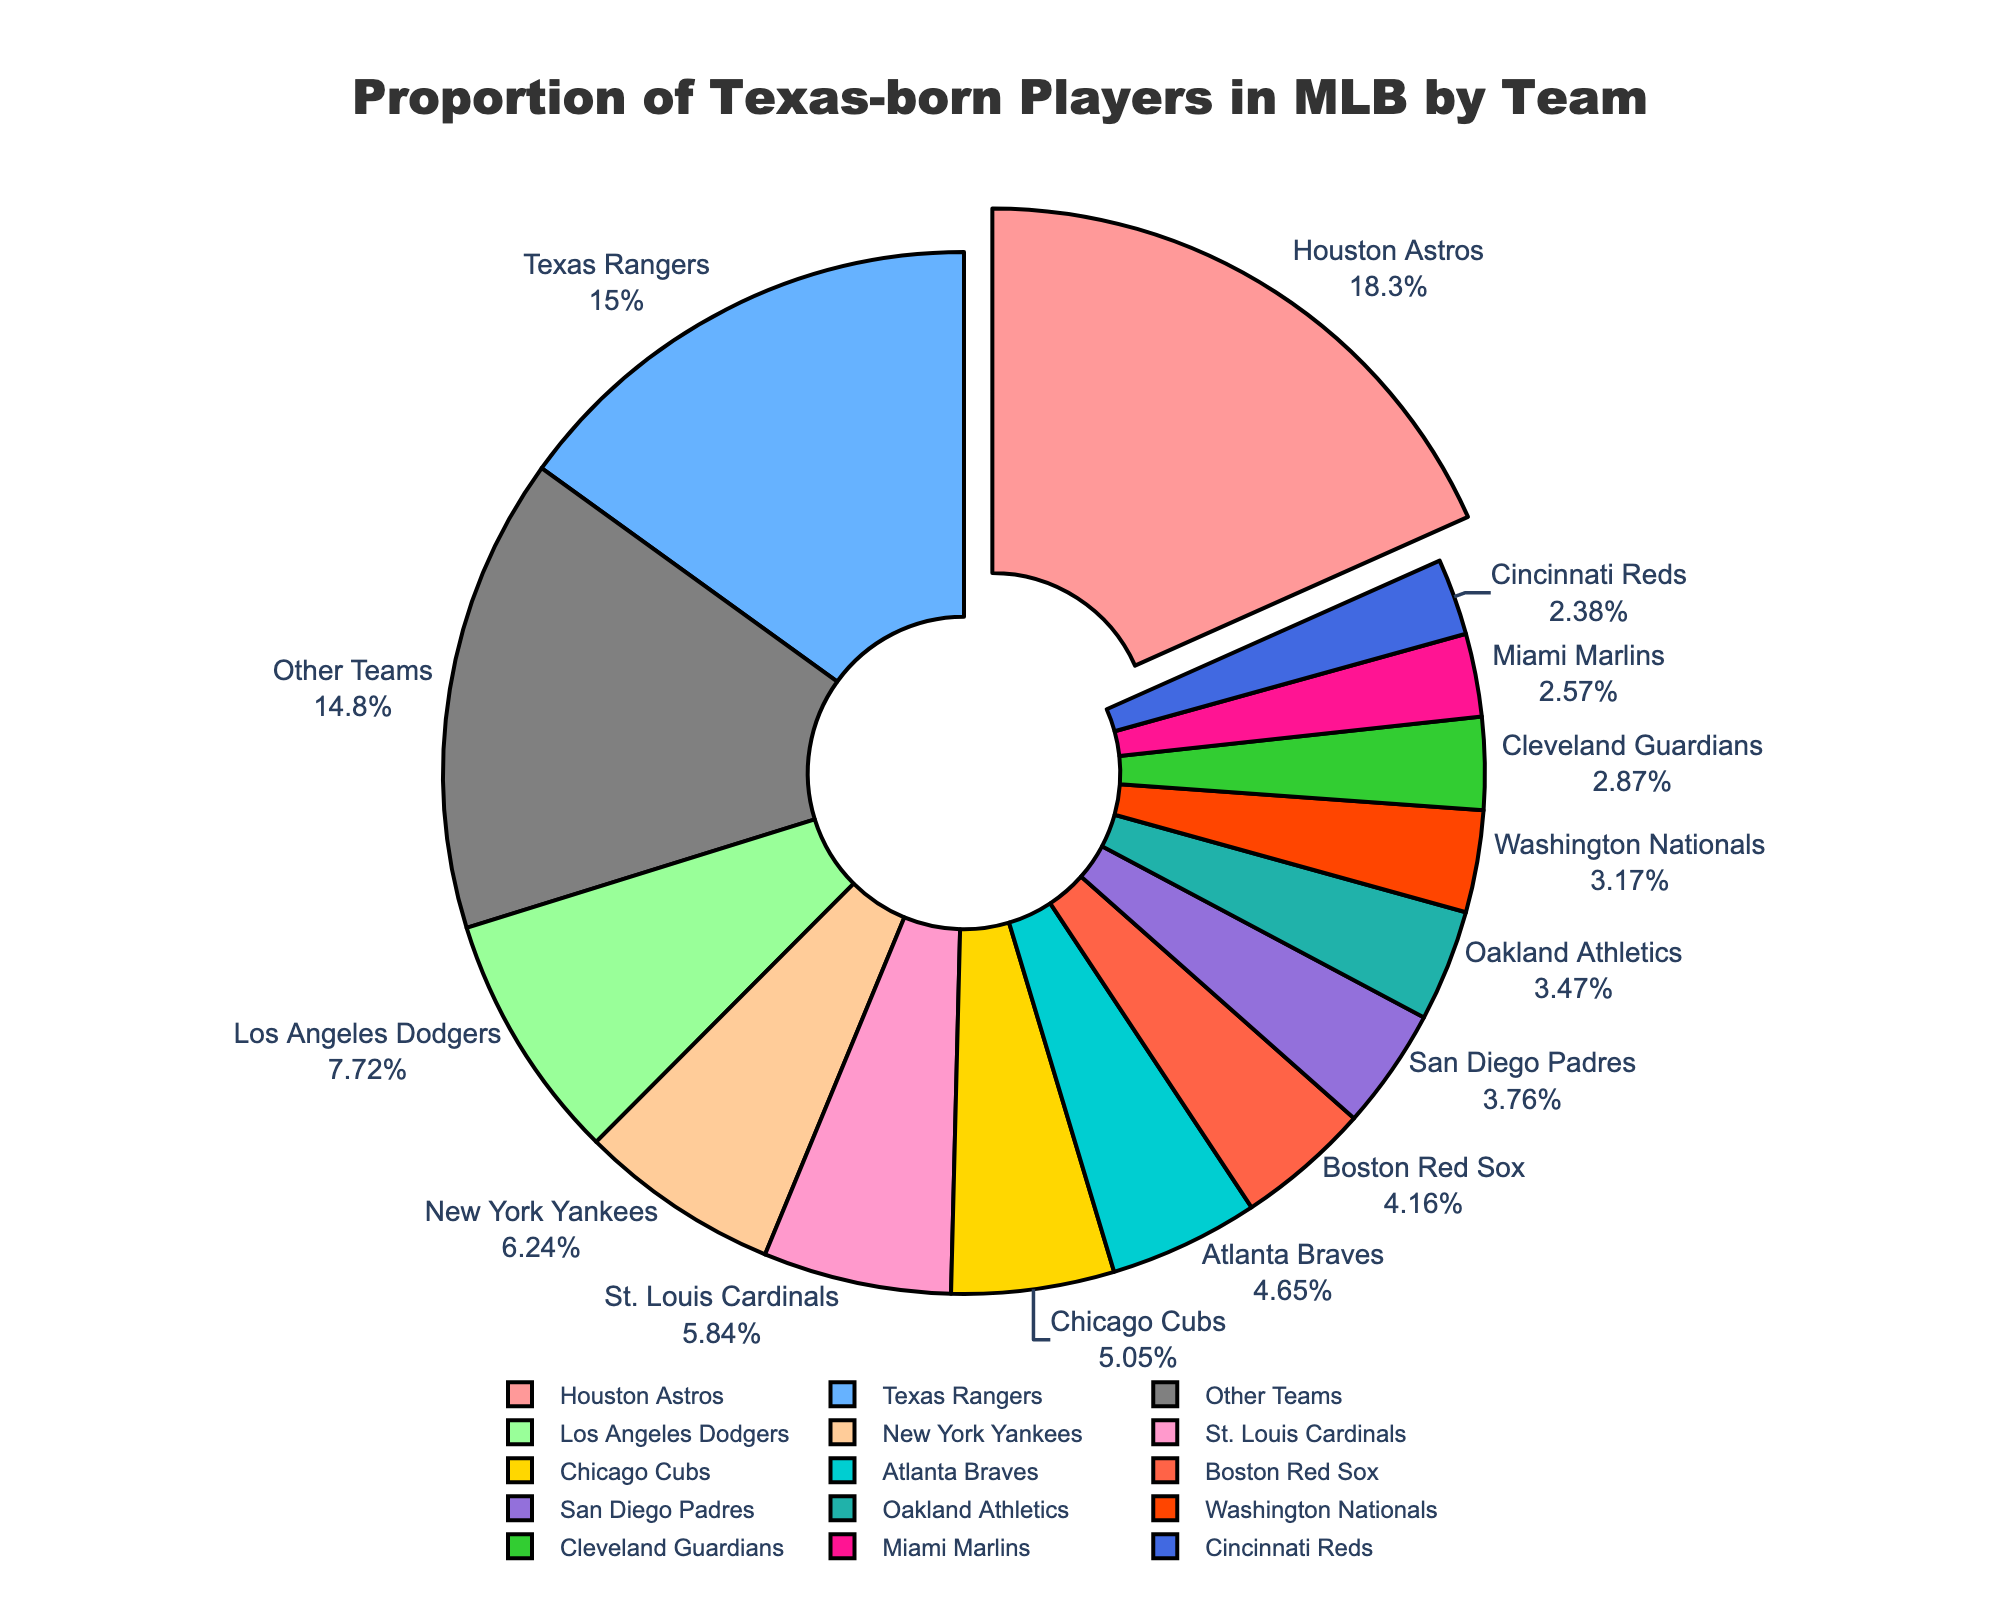Which team has the highest percentage of Texas-born players? The Houston Astros have the highest percentage, which is visually emphasized by the slice size and the "18.5%" label.
Answer: Houston Astros Which team has a higher percentage of Texas-born players, the Texas Rangers or the New York Yankees? Compare the labels, Texas Rangers have "15.2%" whereas New York Yankees have "6.3%", so Texas Rangers have a higher percentage.
Answer: Texas Rangers What is the combined percentage of Texas-born players in the Houston Astros and Texas Rangers? Add the percentages shown for both teams: 18.5% (Astros) + 15.2% (Rangers) = 33.7%.
Answer: 33.7% How does the proportion of Texas-born players in the Houston Astros compare to that in the Los Angeles Dodgers? Houston Astros have 18.5% whereas Los Angeles Dodgers have 7.8%. Houston Astros have a significantly higher proportion.
Answer: Houston Astros What is the proportion of Texas-born players in the "Other Teams" category? The figure shows a slice labeled "Other Teams" with a percentage of 14.9%.
Answer: 14.9% Which team has a smaller percentage of Texas-born players, the Boston Red Sox or the Oakland Athletics? Compare the percentages - Boston Red Sox have 4.2%, and Oakland Athletics have 3.5%. Therefore, Oakland Athletics have a smaller percentage.
Answer: Oakland Athletics Are there more Texas-born players in the Miami Marlins or the Cleveland Guardians? Comparing the percentages, Miami Marlins have 2.6% and Cleveland Guardians have 2.9%, so Cleveland Guardians have more.
Answer: Cleveland Guardians What is the difference in the proportion of Texas-born players between the Chicago Cubs and the Cincinnati Reds? Subtract the smaller percentage from the larger: 5.1% (Cubs) - 2.4% (Reds) = 2.7%.
Answer: 2.7% Which team has the second highest percentage of Texas-born players after the Houston Astros? The next highest percentage after 18.5% is 15.2%, which belongs to the Texas Rangers.
Answer: Texas Rangers Is the percentage of Texas-born players in the Atlanta Braves higher or lower than 5%? The slice for Atlanta Braves is labeled "4.7%", which is lower than 5%.
Answer: Lower 